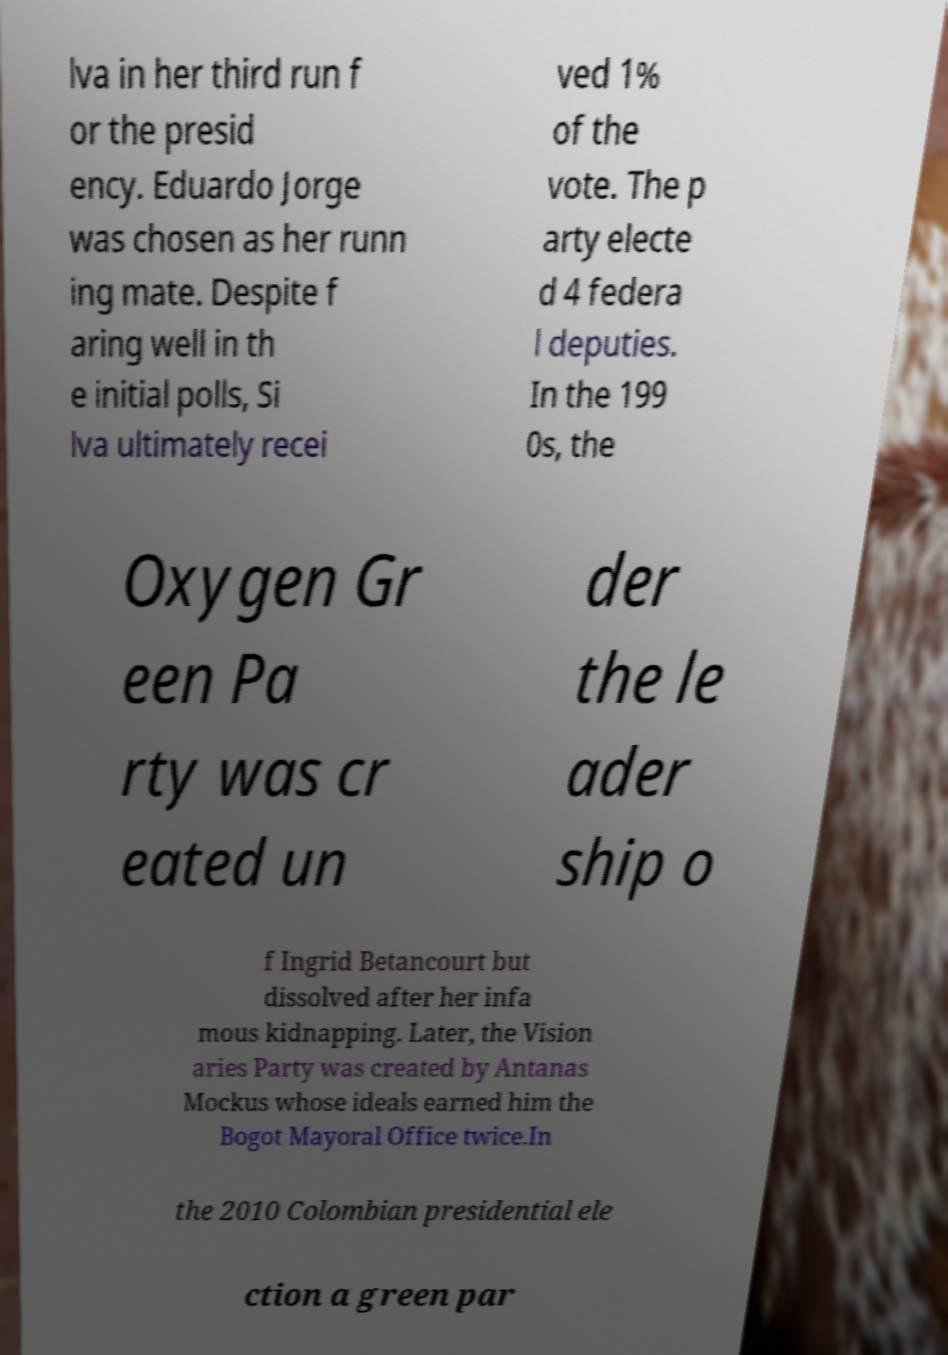Can you read and provide the text displayed in the image?This photo seems to have some interesting text. Can you extract and type it out for me? lva in her third run f or the presid ency. Eduardo Jorge was chosen as her runn ing mate. Despite f aring well in th e initial polls, Si lva ultimately recei ved 1% of the vote. The p arty electe d 4 federa l deputies. In the 199 0s, the Oxygen Gr een Pa rty was cr eated un der the le ader ship o f Ingrid Betancourt but dissolved after her infa mous kidnapping. Later, the Vision aries Party was created by Antanas Mockus whose ideals earned him the Bogot Mayoral Office twice.In the 2010 Colombian presidential ele ction a green par 